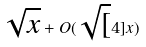Convert formula to latex. <formula><loc_0><loc_0><loc_500><loc_500>\sqrt { x } + O ( \sqrt { [ } 4 ] { x } )</formula> 